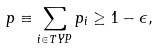Convert formula to latex. <formula><loc_0><loc_0><loc_500><loc_500>p \equiv \sum _ { i \in { T Y P } } p _ { i } \geq 1 - \epsilon ,</formula> 